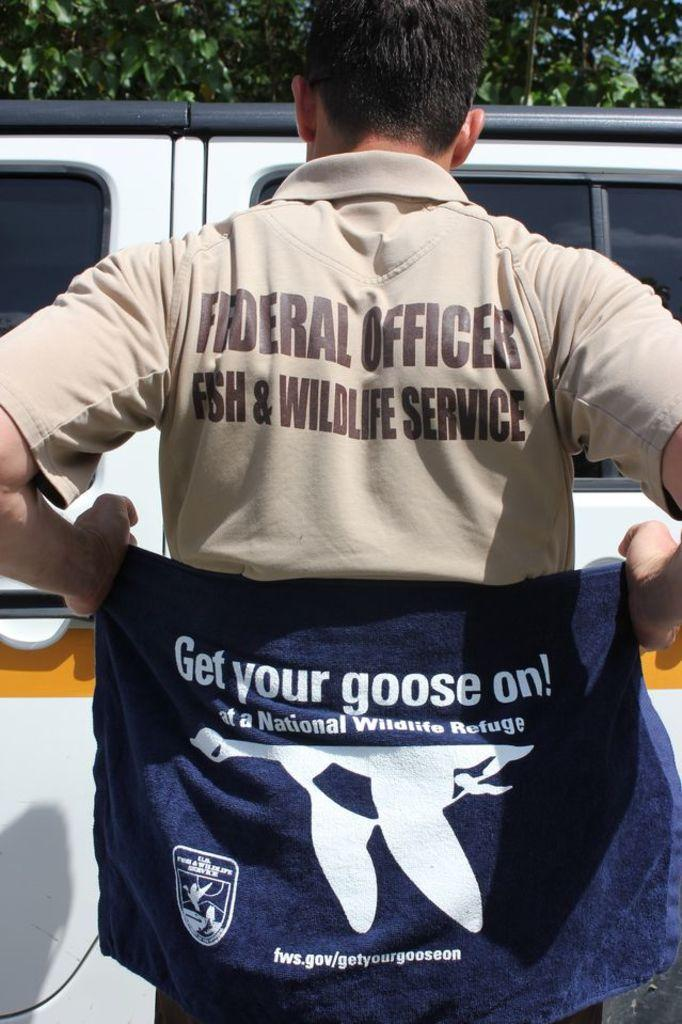<image>
Give a short and clear explanation of the subsequent image. A man wearing a shirt saying is a federal officer with the fish and wildlife service 